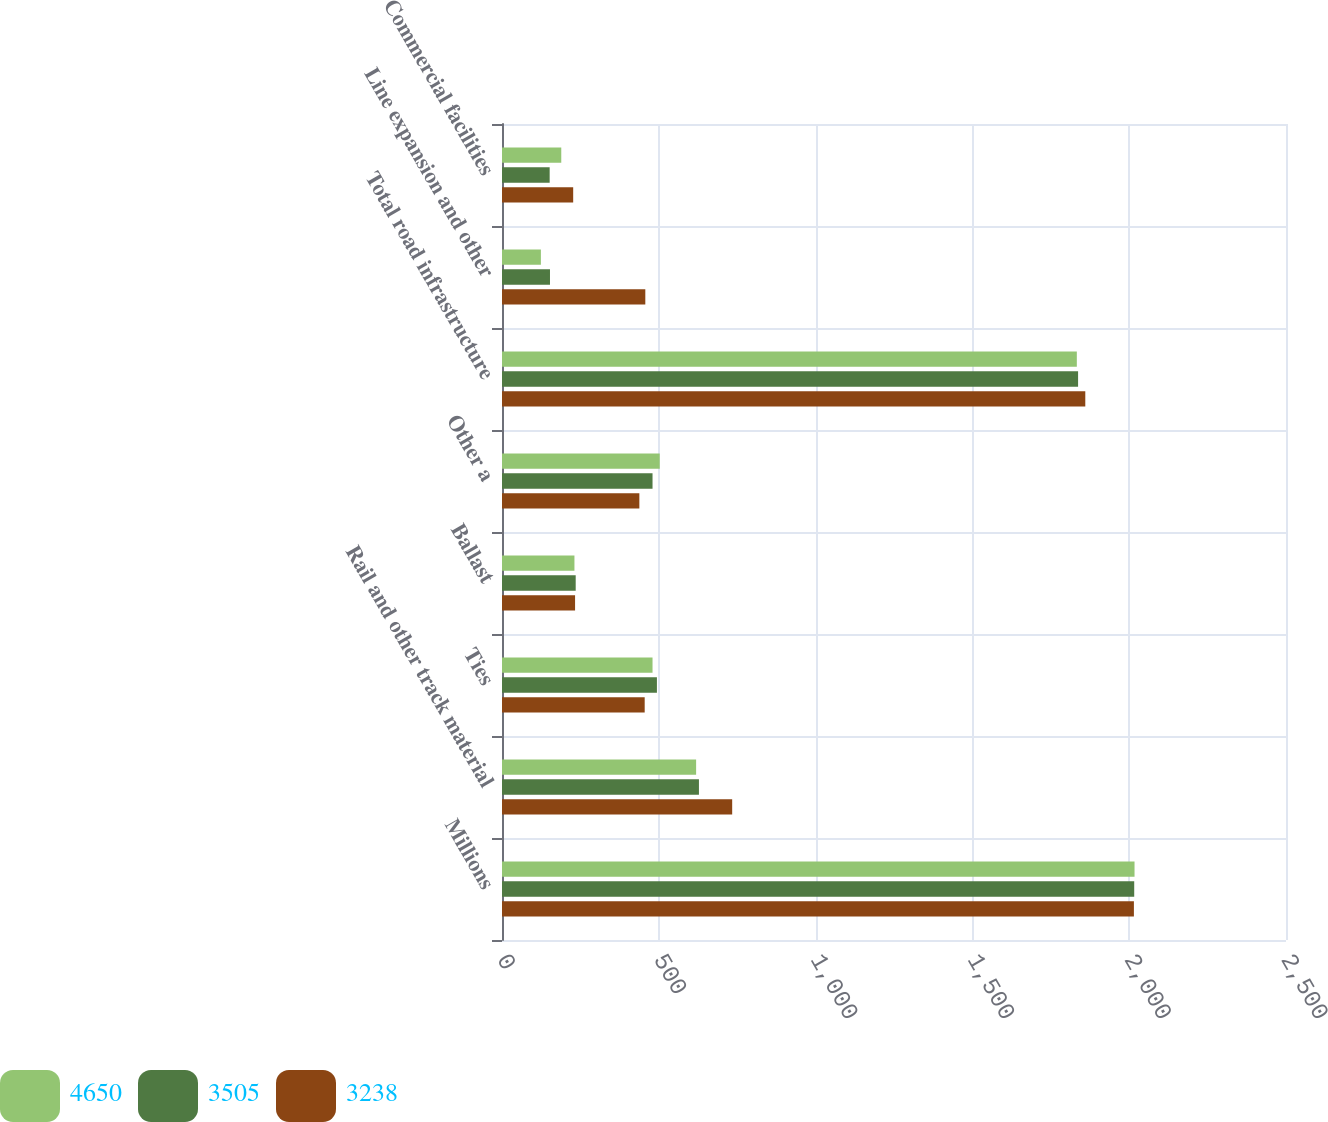Convert chart. <chart><loc_0><loc_0><loc_500><loc_500><stacked_bar_chart><ecel><fcel>Millions<fcel>Rail and other track material<fcel>Ties<fcel>Ballast<fcel>Other a<fcel>Total road infrastructure<fcel>Line expansion and other<fcel>Commercial facilities<nl><fcel>4650<fcel>2017<fcel>619<fcel>480<fcel>231<fcel>503<fcel>1833<fcel>124<fcel>189<nl><fcel>3505<fcel>2016<fcel>628<fcel>494<fcel>235<fcel>480<fcel>1837<fcel>153<fcel>152<nl><fcel>3238<fcel>2015<fcel>734<fcel>455<fcel>233<fcel>438<fcel>1860<fcel>457<fcel>227<nl></chart> 